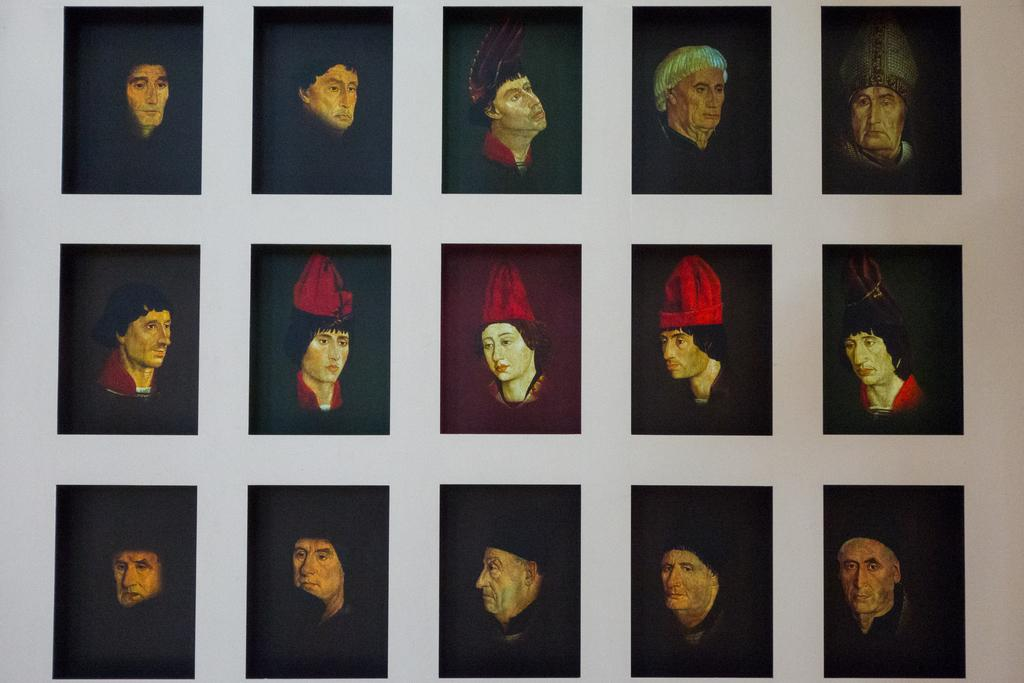What is depicted in the image? There are paintings in the image. What is the paintings placed on? The paintings are on a black cloth. Where is the black cloth with the paintings located? The black cloth with the paintings is placed on a wall. How many snails can be seen crawling on the paintings in the image? There are no snails present in the image; it only features paintings on a black cloth placed on a wall. 